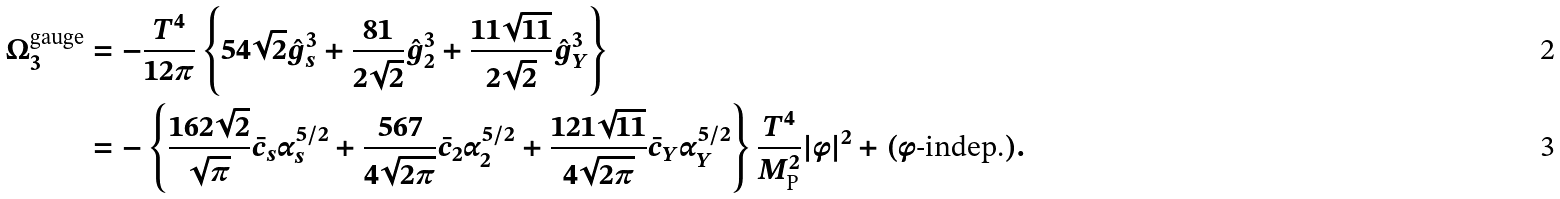Convert formula to latex. <formula><loc_0><loc_0><loc_500><loc_500>\Omega _ { 3 } ^ { \text {gauge} } & = - \frac { T ^ { 4 } } { 1 2 \pi } \left \{ 5 4 \sqrt { 2 } \hat { g } _ { s } ^ { 3 } + \frac { 8 1 } { 2 \sqrt { 2 } } \hat { g } _ { 2 } ^ { 3 } + \frac { 1 1 \sqrt { 1 1 } } { 2 \sqrt { 2 } } \hat { g } _ { Y } ^ { 3 } \right \} \\ & = - \left \{ \frac { 1 6 2 \sqrt { 2 } } { \sqrt { \pi } } \bar { c } _ { s } \alpha _ { s } ^ { 5 / 2 } + \frac { 5 6 7 } { 4 \sqrt { 2 \pi } } \bar { c } _ { 2 } \alpha _ { 2 } ^ { 5 / 2 } + \frac { 1 2 1 \sqrt { 1 1 } } { 4 \sqrt { 2 \pi } } \bar { c } _ { Y } \alpha _ { Y } ^ { 5 / 2 } \right \} \frac { T ^ { 4 } } { M _ { \text {P} } ^ { 2 } } | \phi | ^ { 2 } + ( \phi \text {-indep.} ) .</formula> 